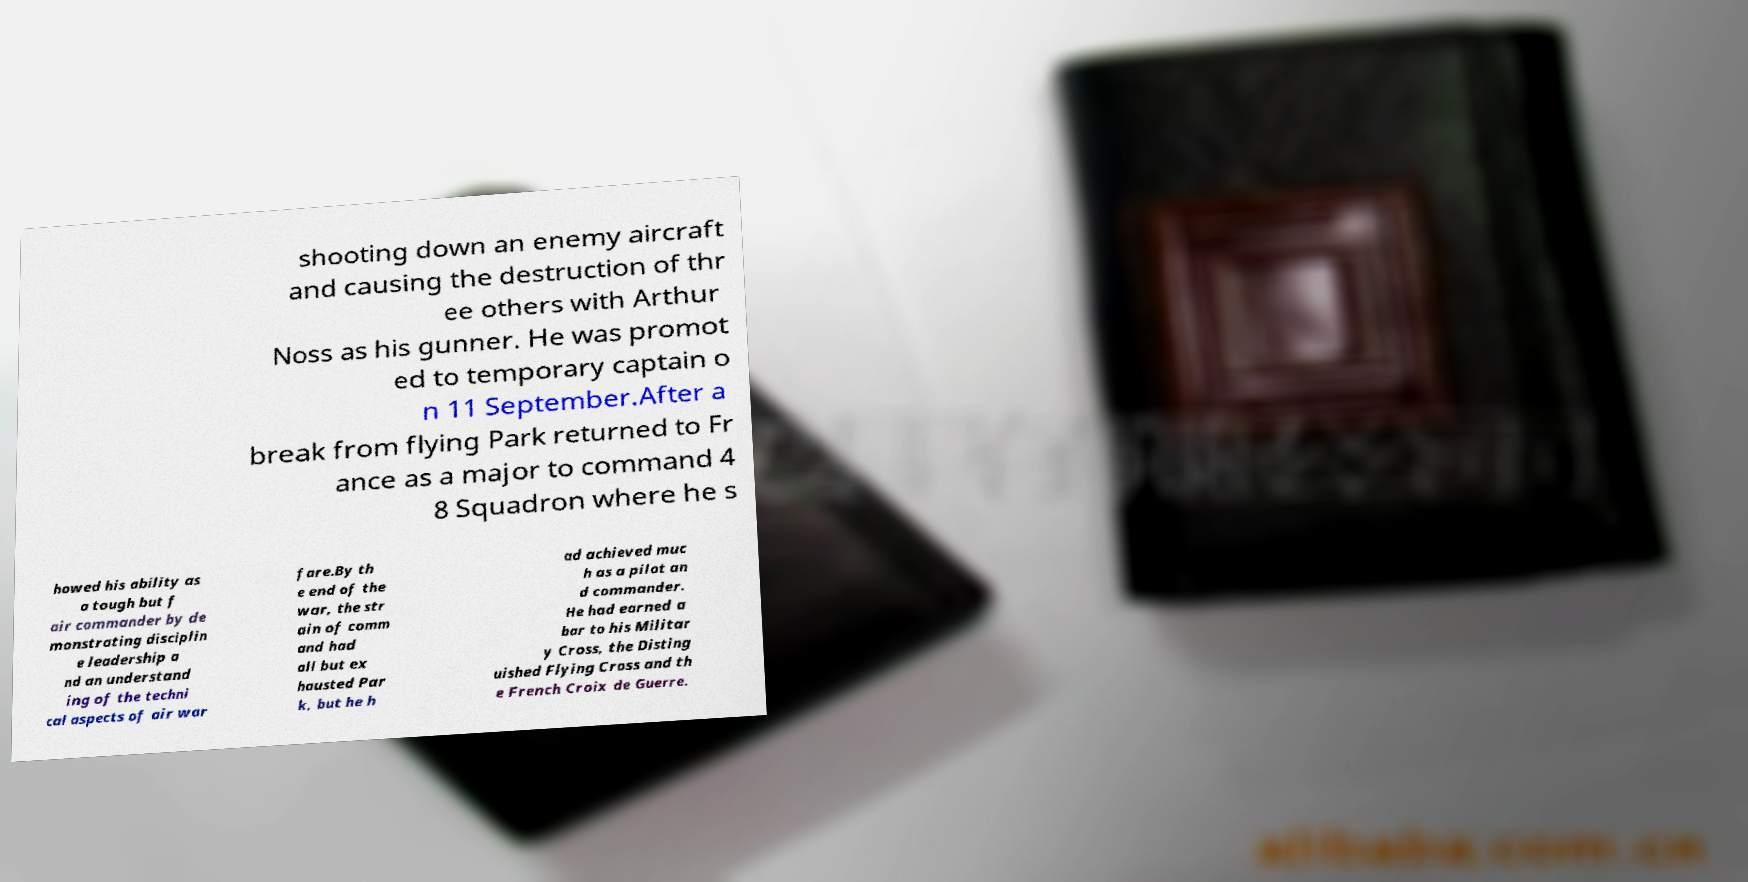Could you extract and type out the text from this image? shooting down an enemy aircraft and causing the destruction of thr ee others with Arthur Noss as his gunner. He was promot ed to temporary captain o n 11 September.After a break from flying Park returned to Fr ance as a major to command 4 8 Squadron where he s howed his ability as a tough but f air commander by de monstrating disciplin e leadership a nd an understand ing of the techni cal aspects of air war fare.By th e end of the war, the str ain of comm and had all but ex hausted Par k, but he h ad achieved muc h as a pilot an d commander. He had earned a bar to his Militar y Cross, the Disting uished Flying Cross and th e French Croix de Guerre. 